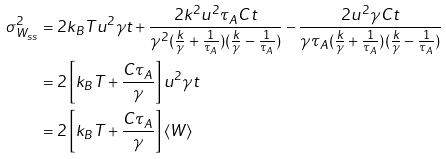<formula> <loc_0><loc_0><loc_500><loc_500>\sigma _ { W _ { s s } } ^ { 2 } & = 2 k _ { B } T u ^ { 2 } \gamma t + \frac { 2 k ^ { 2 } u ^ { 2 } \tau _ { A } C t } { { \gamma ^ { 2 } { ( \frac { k } { \gamma } + \frac { 1 } { \tau _ { A } } ) } ( \frac { k } { \gamma } - \frac { 1 } { \tau _ { A } } ) } } - \frac { 2 u ^ { 2 } \gamma C t } { { \gamma \tau _ { A } { ( \frac { k } { \gamma } + \frac { 1 } { \tau _ { A } } ) } ( \frac { k } { \gamma } - \frac { 1 } { \tau _ { A } } ) } } \\ & = 2 \left [ k _ { B } T + \frac { C \tau _ { A } } { \gamma } \right ] u ^ { 2 } \gamma t \\ & = 2 \left [ k _ { B } T + \frac { C \tau _ { A } } { \gamma } \right ] \left < W \right ></formula> 